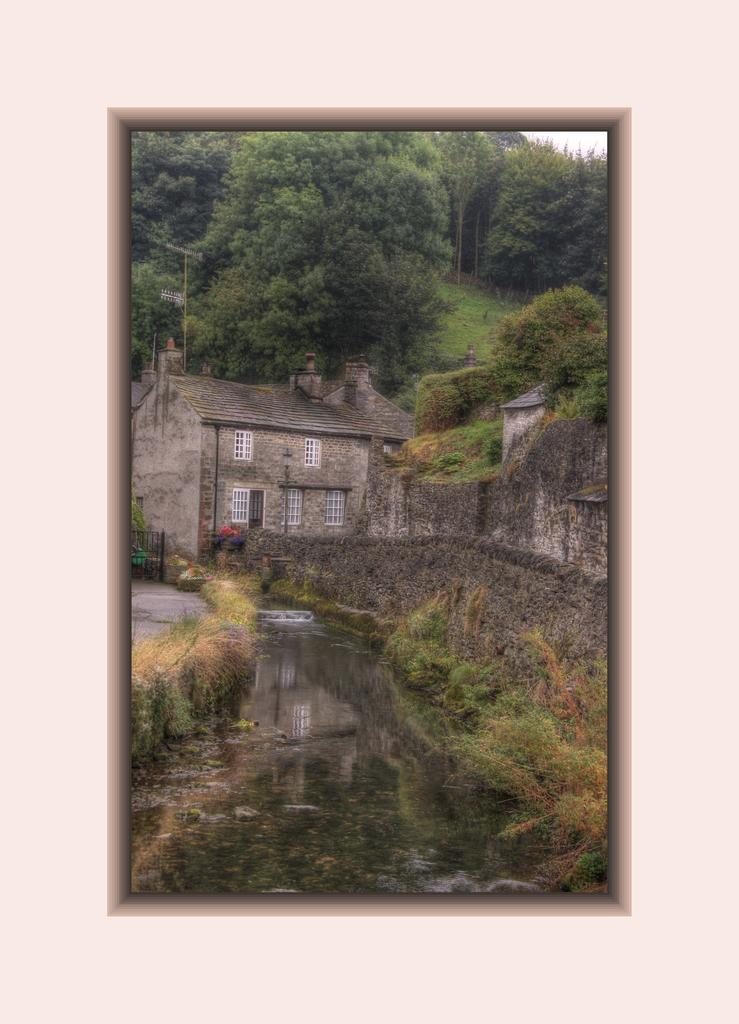What object can be seen in the image that typically holds a photograph? There is a photo frame in the image. What is present at the bottom of the image? There is water at the bottom of the image. What structure is located in the middle of the image? There is a building in the middle of the image. What type of vegetation can be seen in the background of the image? There are trees in the background of the image. Can you tell if any editing has been done to the image? Yes, the image appears to be edited. What type of riddle can be seen in the image? There is no riddle present in the image. How many bees are visible in the image? There are no bees present in the image. 